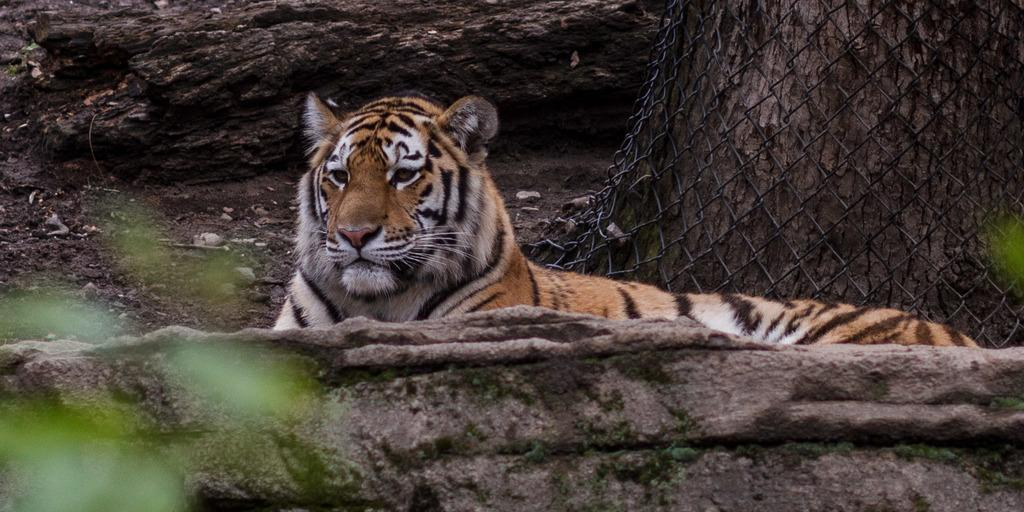What animal is the main subject of the image? There is a tiger in the image. What is the tiger doing in the image? The tiger is sitting on the ground. What can be seen in the background of the image? There is an open land in the background of the image. What is located on the right side of the image? There is a tree on the right side of the image. Can you hear the tiger sneeze in the image? There is no sound in the image, so it is not possible to hear the tiger sneeze. Are there any dinosaurs visible in the image? No, there are no dinosaurs present in the image; it features a tiger sitting on the ground. 